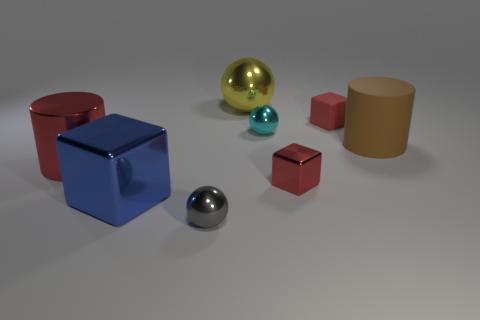What is the texture and finish of the objects? The objects have a variety of finishes. The spheres have a smooth and shiny texture, suggesting they are metallic or polished. The cubes exhibit a matte finish with slight reflections, indicating they are likely metallic but with a coating that diffuses light rather than reflecting it sharply. 